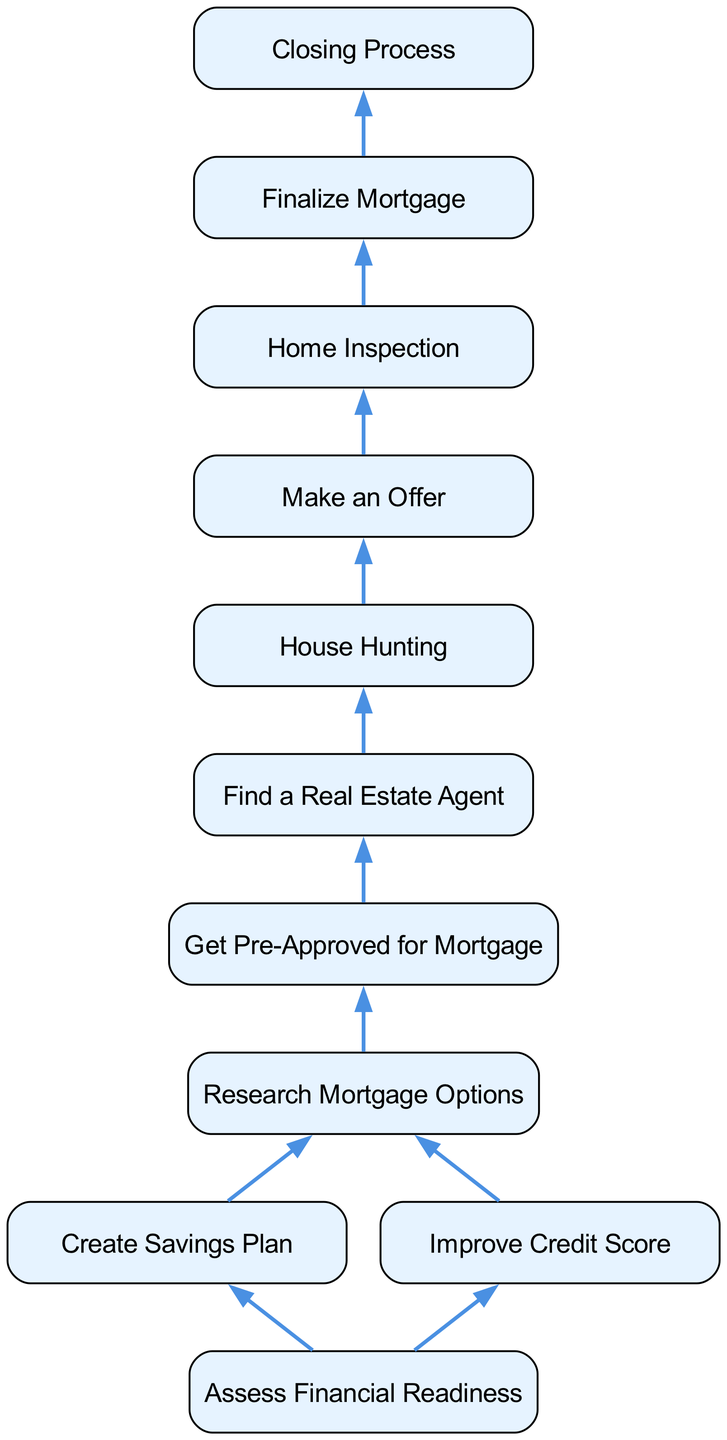What is the first step in the home buying process? The first step in the diagram is represented by the node "Assess Financial Readiness," which indicates the starting point of the process for potential homebuyers.
Answer: Assess Financial Readiness How many total nodes are in the diagram? The diagram contains a total of 11 nodes, each representing a significant step in the home buying process.
Answer: 11 What step comes after "Improve Credit Score"? Following "Improve Credit Score," the next step in the flow is "Research Mortgage Options," which is linked directly in the diagram.
Answer: Research Mortgage Options What is the last step in the home buying process? The final step depicted in the diagram is "Closing Process," which indicates the completion of the home buying journey.
Answer: Closing Process How many edges connect "House Hunting" to other steps? The node "House Hunting" connects to one other node, which is "Make an Offer," indicating a singular link in the flow of the process.
Answer: 1 What is the relationship between "Get Pre-Approved for Mortgage" and "Find a Real Estate Agent"? "Get Pre-Approved for Mortgage" leads directly to "Find a Real Estate Agent," demonstrating a sequential relationship where mortgage pre-approval is necessary before engaging an agent.
Answer: Direct connection What is the second step in the home buying process? The second step after "Assess Financial Readiness" is "Create Savings Plan," which logically follows the assessment of one's financial standings.
Answer: Create Savings Plan Which step follows "Make an Offer"? The next step after "Make an Offer" is "Home Inspection," showing the importance of inspecting a property after an offer has been accepted.
Answer: Home Inspection What are the first two steps in the flow? The first two steps, as indicated in the diagram, are "Assess Financial Readiness" followed by "Create Savings Plan," which establishes a foundation for the subsequent actions in the home buying process.
Answer: Assess Financial Readiness, Create Savings Plan 